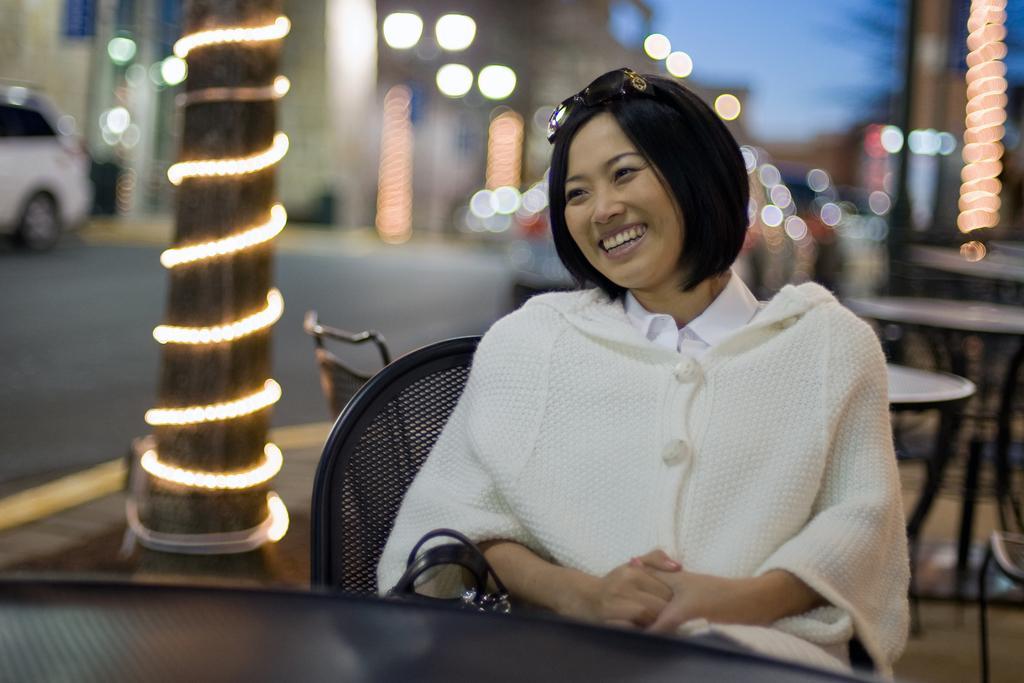Can you describe this image briefly? This picture shows a woman smiling and sitting in the chair in front of a table. In the background there is a pillar decorated with lights and some buildings here. 